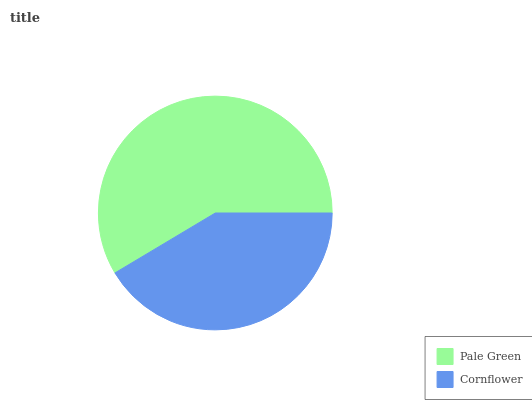Is Cornflower the minimum?
Answer yes or no. Yes. Is Pale Green the maximum?
Answer yes or no. Yes. Is Cornflower the maximum?
Answer yes or no. No. Is Pale Green greater than Cornflower?
Answer yes or no. Yes. Is Cornflower less than Pale Green?
Answer yes or no. Yes. Is Cornflower greater than Pale Green?
Answer yes or no. No. Is Pale Green less than Cornflower?
Answer yes or no. No. Is Pale Green the high median?
Answer yes or no. Yes. Is Cornflower the low median?
Answer yes or no. Yes. Is Cornflower the high median?
Answer yes or no. No. Is Pale Green the low median?
Answer yes or no. No. 